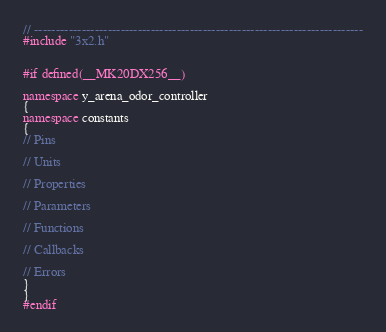<code> <loc_0><loc_0><loc_500><loc_500><_C++_>// ----------------------------------------------------------------------------
#include "3x2.h"


#if defined(__MK20DX256__)

namespace y_arena_odor_controller
{
namespace constants
{
// Pins

// Units

// Properties

// Parameters

// Functions

// Callbacks

// Errors
}
}
#endif
</code> 